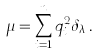Convert formula to latex. <formula><loc_0><loc_0><loc_500><loc_500>\mu = \sum _ { i = 1 } ^ { n } q _ { i } ^ { 2 } \delta _ { \lambda _ { i } } .</formula> 